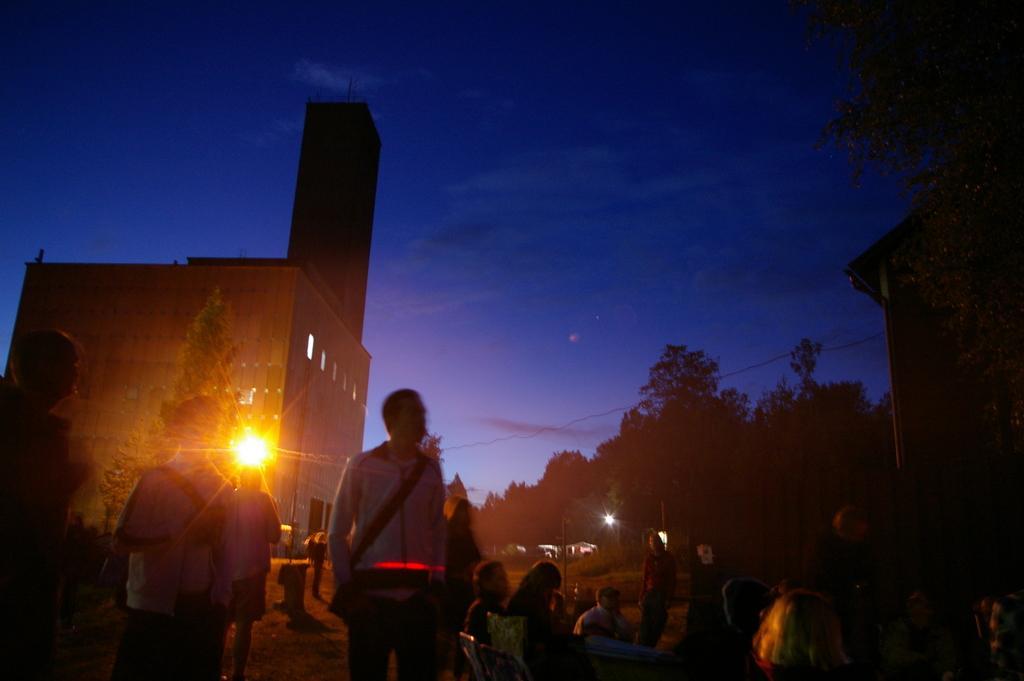In one or two sentences, can you explain what this image depicts? In this image we can see some group of persons standing and some are sitting and in the background of the image there are some trees, buildings, lights and clear sky. 